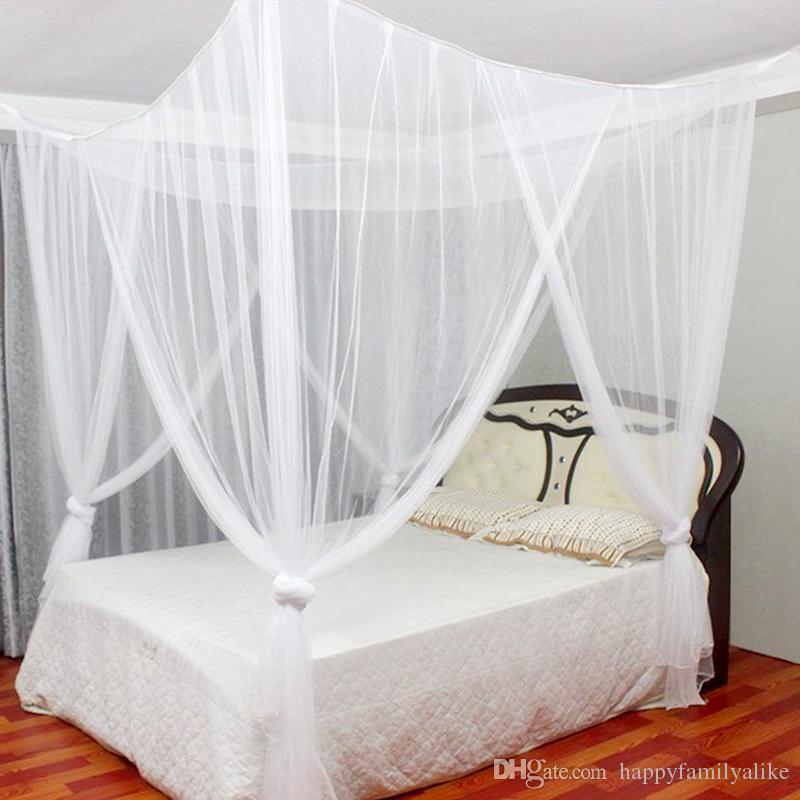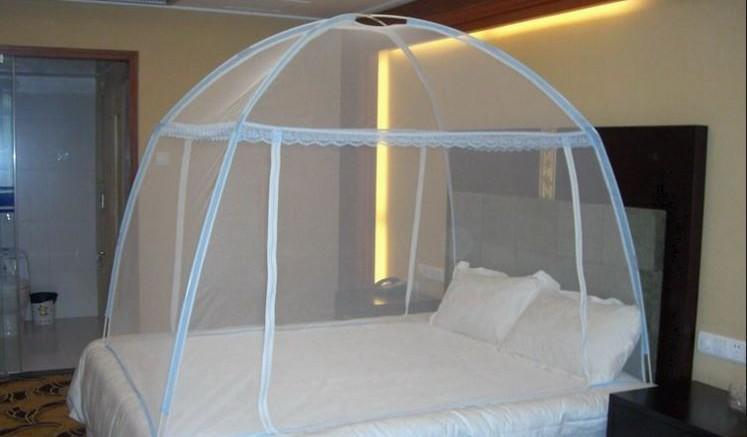The first image is the image on the left, the second image is the image on the right. Given the left and right images, does the statement "The right net/drape has a cone on the top." hold true? Answer yes or no. No. The first image is the image on the left, the second image is the image on the right. For the images shown, is this caption "There are  two canopies that white beds and at least one is square." true? Answer yes or no. Yes. 